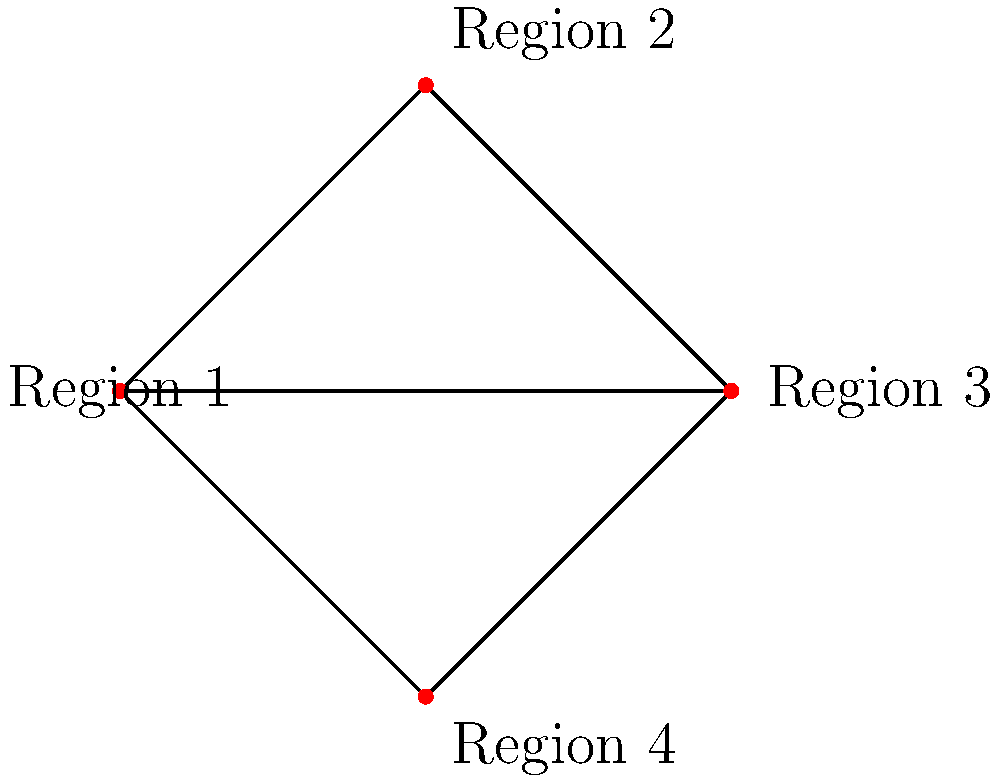In the map shown above, each region shares a border with every other region. What is the minimum number of colors needed to color the regions so that no two adjacent regions have the same color? To determine the minimum number of colors needed, we can follow these steps:

1. Observe that each region shares a border with every other region. This means the map forms a complete graph with 4 vertices.

2. In graph theory, the minimum number of colors needed to color a complete graph is equal to the number of vertices in the graph.

3. Count the number of regions (vertices) in the map:
   Region 1, Region 2, Region 3, and Region 4.
   There are 4 regions in total.

4. Since we have a complete graph with 4 vertices, we need at least 4 colors to ensure that no two adjacent regions have the same color.

5. We can verify this by trying to color the map with fewer colors:
   - With 1 color: Impossible, as all regions would have the same color.
   - With 2 colors: Impossible, as at least two adjacent regions would have the same color.
   - With 3 colors: Impossible, as we would run out of colors for the fourth region.

Therefore, the minimum number of colors needed is 4.
Answer: 4 colors 